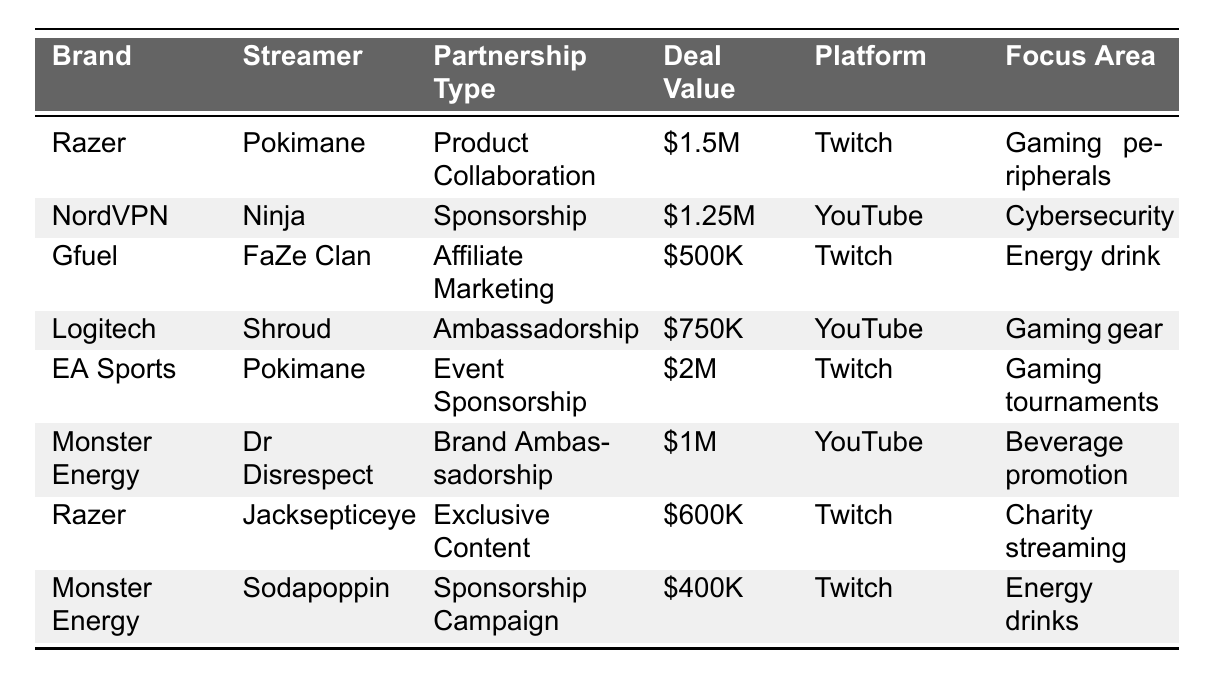What is the highest deal value in the table? The highest deal value listed in the table is associated with EA Sports and Pokimane at $2M.
Answer: $2M Which streamer has the most brand partnerships listed? Pokimane has two brand partnerships listed: one with Razer and one with EA Sports.
Answer: Pokimane What is the total deal value of all partnerships in 2022? To find the total deal value, we sum all the deal values: $1.5M + $1.25M + $0.5M + $0.75M + $2M + $1M + $0.6M + $0.4M = $8.1M.
Answer: $8.1M Is there any sponsorship for the brand "Monster Energy"? Yes, there are two sponsorships for "Monster Energy": one with Dr Disrespect and another with Sodapoppin.
Answer: Yes What is the average deal value for Twitch partnerships? The deal values for Twitch partnerships are $1.5M, $500K, $2M, $600K, and $400K. The total is $1.5M + $0.5M + $2M + $0.6M + $0.4M = $5M. There are 5 Twitch partnerships, so the average is $5M/5 = $1M.
Answer: $1M Which partnership type has the lowest value? The partnership type with the lowest value is the Sponsorship Campaign with Monster Energy and Sodapoppin, valued at $400K.
Answer: Sponsorship Campaign How many different platforms are represented in this table? The platforms represented are Twitch and YouTube. Counting the unique platforms gives us 2.
Answer: 2 Are there any partnerships focused on "Gaming peripherals"? Yes, the partnership between Razer and Pokimane is focused on "Gaming peripherals."
Answer: Yes What is the total deal value for partnerships related to 'Energy drinks'? The partnerships related to 'Energy drinks' are with Gfuel ($500K) and Monster Energy ($400K), totaling $500K + $400K = $900K.
Answer: $900K Which brand partnered with the highest value on the YouTube platform? The highest value partnership on YouTube is with Logitech and Shroud at $750K.
Answer: $750K 